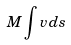<formula> <loc_0><loc_0><loc_500><loc_500>M \int v d s</formula> 